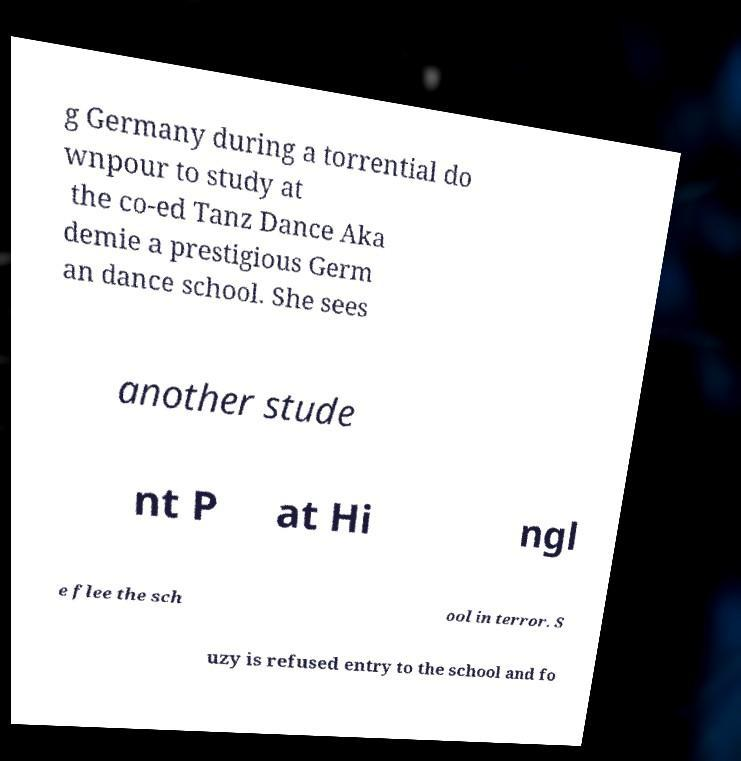Could you assist in decoding the text presented in this image and type it out clearly? g Germany during a torrential do wnpour to study at the co-ed Tanz Dance Aka demie a prestigious Germ an dance school. She sees another stude nt P at Hi ngl e flee the sch ool in terror. S uzy is refused entry to the school and fo 